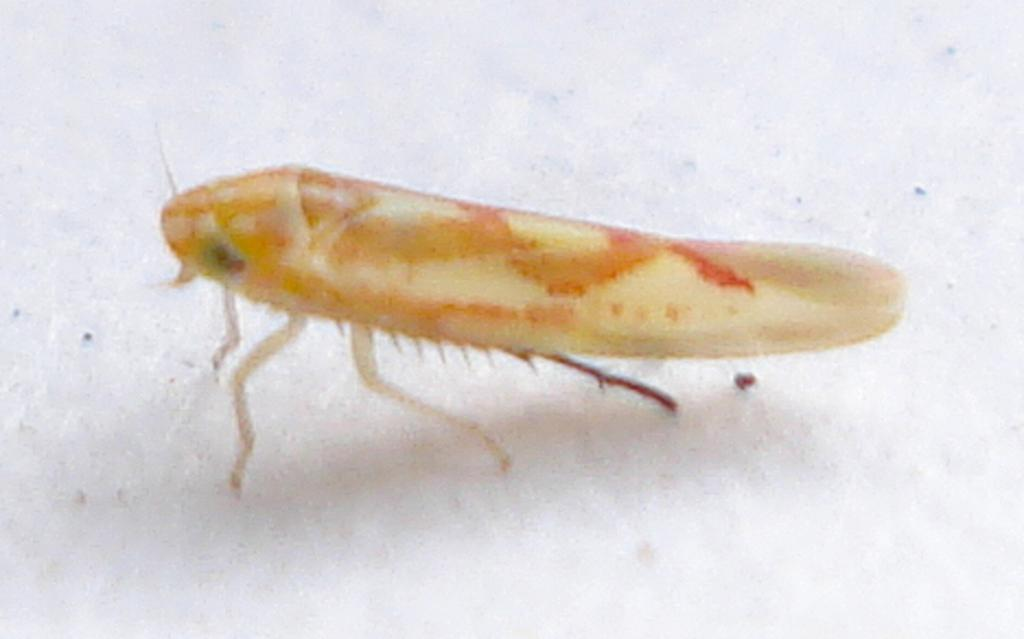What type of creature can be seen in the image? There is an insect in the image. What is the insect doing in the image? The insect is standing on a surface. What color is the background of the image? The background of the image is white. Can you see any leaves on the insect in the image? There are no leaves present in the image; it features an insect standing on a surface with a white background. 